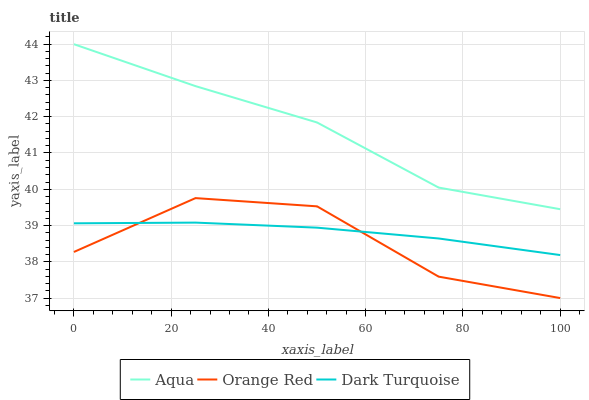Does Aqua have the minimum area under the curve?
Answer yes or no. No. Does Orange Red have the maximum area under the curve?
Answer yes or no. No. Is Aqua the smoothest?
Answer yes or no. No. Is Aqua the roughest?
Answer yes or no. No. Does Aqua have the lowest value?
Answer yes or no. No. Does Orange Red have the highest value?
Answer yes or no. No. Is Dark Turquoise less than Aqua?
Answer yes or no. Yes. Is Aqua greater than Orange Red?
Answer yes or no. Yes. Does Dark Turquoise intersect Aqua?
Answer yes or no. No. 